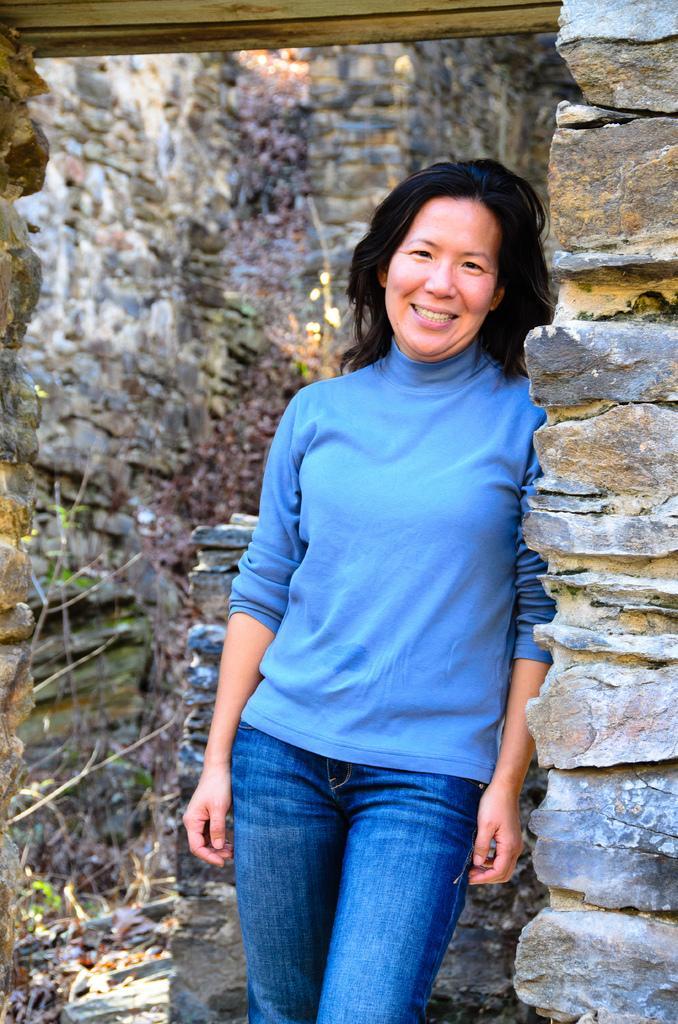Describe this image in one or two sentences. In this image we can see a woman and she is smiling. In the background we can see wall. 